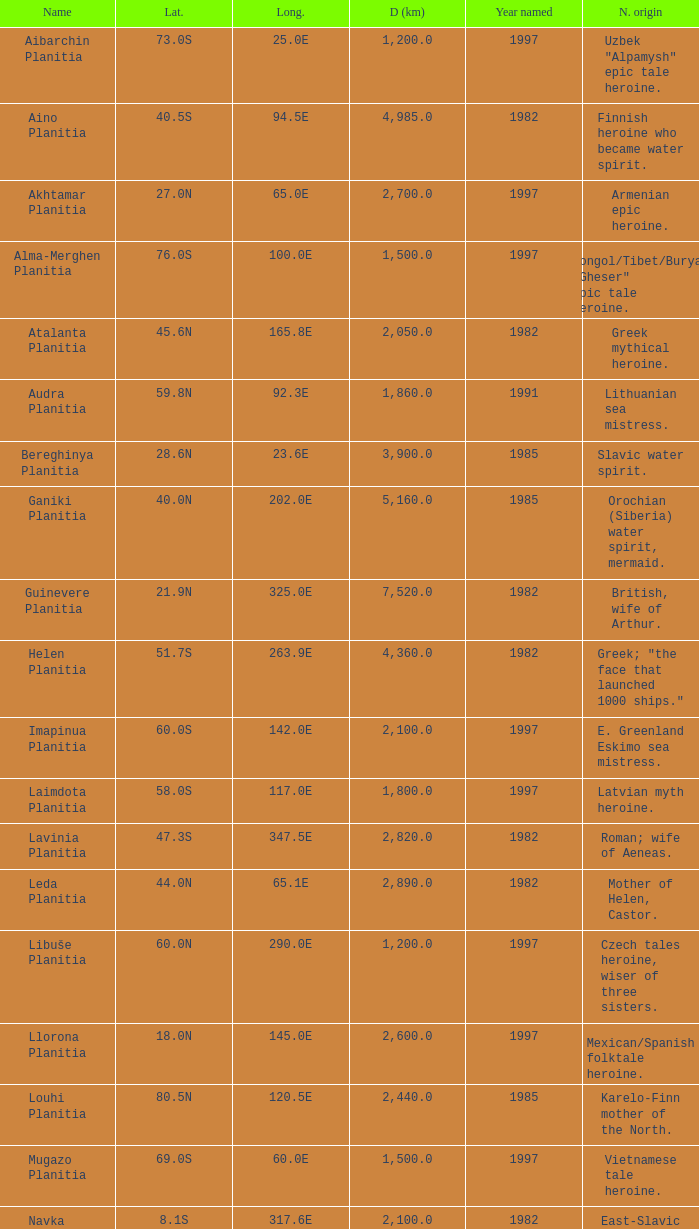What is the latitude of the feature of longitude 80.0e 23.0S. 